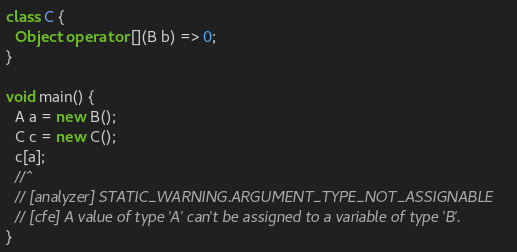<code> <loc_0><loc_0><loc_500><loc_500><_Dart_>
class C {
  Object operator [](B b) => 0;
}

void main() {
  A a = new B();
  C c = new C();
  c[a];
  //^
  // [analyzer] STATIC_WARNING.ARGUMENT_TYPE_NOT_ASSIGNABLE
  // [cfe] A value of type 'A' can't be assigned to a variable of type 'B'.
}
</code> 